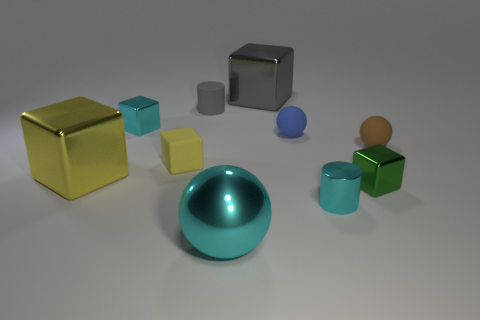Subtract all yellow cubes. How many were subtracted if there are1yellow cubes left? 1 Subtract 2 blocks. How many blocks are left? 3 Subtract all purple cubes. Subtract all blue cylinders. How many cubes are left? 5 Subtract all balls. How many objects are left? 7 Add 4 blocks. How many blocks exist? 9 Subtract 0 brown cylinders. How many objects are left? 10 Subtract all cyan shiny things. Subtract all blue spheres. How many objects are left? 6 Add 9 blue matte things. How many blue matte things are left? 10 